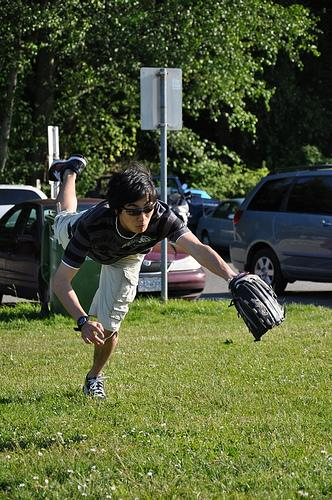What handedness does this person have? Please explain your reasoning. right. A person is wearing a baseball glove on their left hand. 